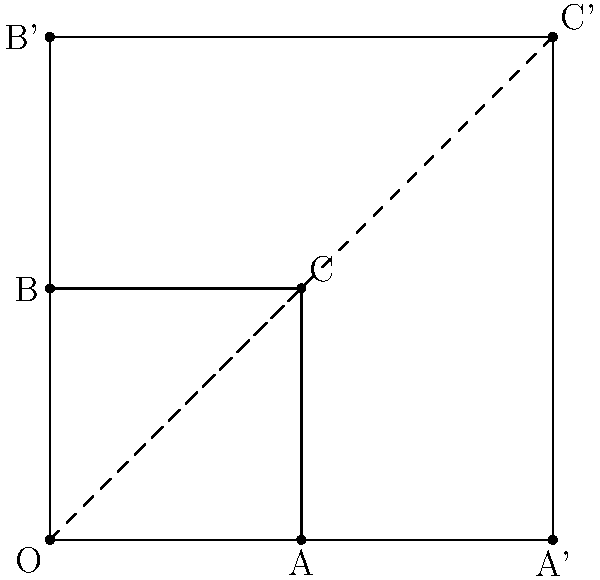In a pediatric mental health assessment, you use a square diagram to represent a child's emotional state. The original square OABC represents a baseline state. After treatment, the square is scaled by a factor of 2 from point O to form OA'B'C'. How does the area of OA'B'C' compare to the area of OABC? Let's approach this step-by-step:

1) First, we need to understand what scaling by a factor of 2 means. It means that all distances from the fixed point O are doubled.

2) The area of a square is given by the square of its side length. Let's say the side length of OABC is $s$.

3) The area of the original square OABC is therefore $A_1 = s^2$.

4) After scaling, the side length of OA'B'C' is $2s$.

5) The area of the scaled square OA'B'C' is therefore $A_2 = (2s)^2 = 4s^2$.

6) To compare the areas, we can divide $A_2$ by $A_1$:

   $\frac{A_2}{A_1} = \frac{4s^2}{s^2} = 4$

7) This means that the area of OA'B'C' is 4 times the area of OABC.

In the context of the pediatric mental health assessment, this could represent a significant improvement in the child's emotional state, with the larger area potentially indicating a broader range of positive emotions or improved coping mechanisms.
Answer: 4 times larger 